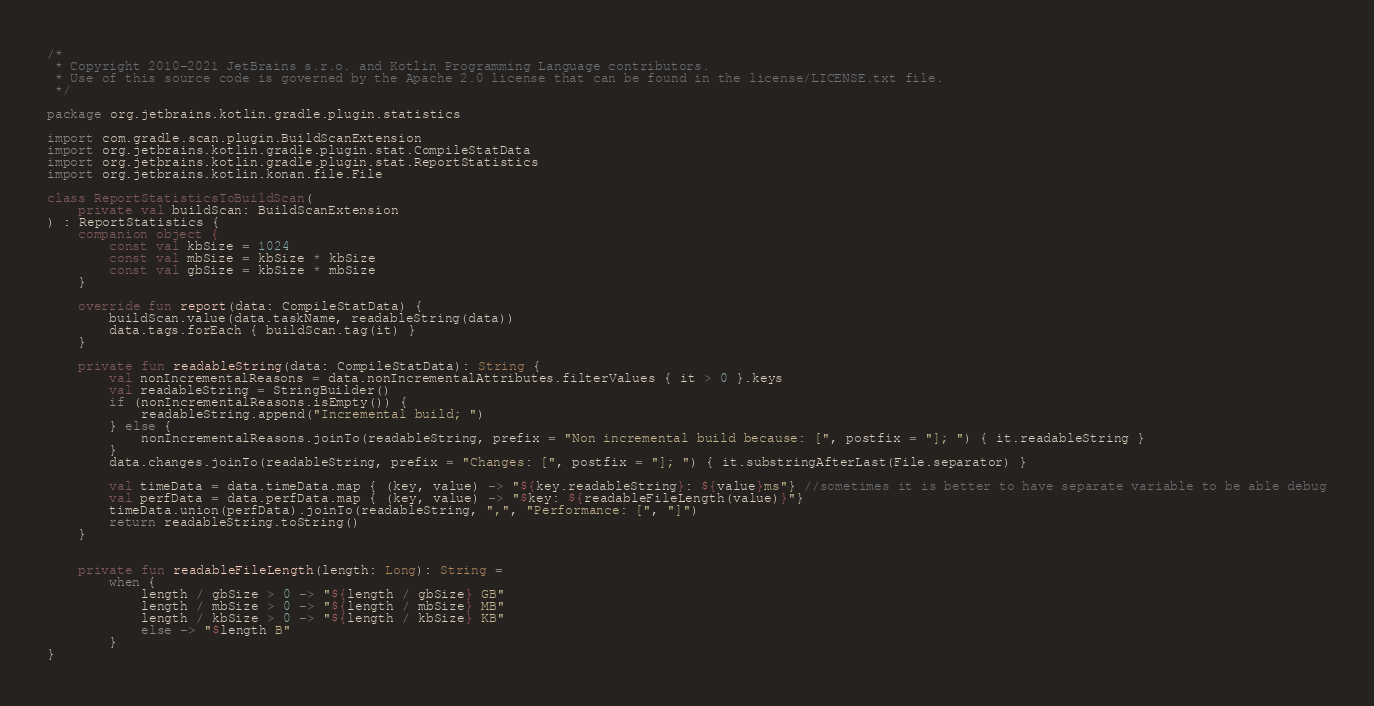Convert code to text. <code><loc_0><loc_0><loc_500><loc_500><_Kotlin_>/*
 * Copyright 2010-2021 JetBrains s.r.o. and Kotlin Programming Language contributors.
 * Use of this source code is governed by the Apache 2.0 license that can be found in the license/LICENSE.txt file.
 */

package org.jetbrains.kotlin.gradle.plugin.statistics

import com.gradle.scan.plugin.BuildScanExtension
import org.jetbrains.kotlin.gradle.plugin.stat.CompileStatData
import org.jetbrains.kotlin.gradle.plugin.stat.ReportStatistics
import org.jetbrains.kotlin.konan.file.File

class ReportStatisticsToBuildScan(
    private val buildScan: BuildScanExtension
) : ReportStatistics {
    companion object {
        const val kbSize = 1024
        const val mbSize = kbSize * kbSize
        const val gbSize = kbSize * mbSize
    }

    override fun report(data: CompileStatData) {
        buildScan.value(data.taskName, readableString(data))
        data.tags.forEach { buildScan.tag(it) }
    }

    private fun readableString(data: CompileStatData): String {
        val nonIncrementalReasons = data.nonIncrementalAttributes.filterValues { it > 0 }.keys
        val readableString = StringBuilder()
        if (nonIncrementalReasons.isEmpty()) {
            readableString.append("Incremental build; ")
        } else {
            nonIncrementalReasons.joinTo(readableString, prefix = "Non incremental build because: [", postfix = "]; ") { it.readableString }
        }
        data.changes.joinTo(readableString, prefix = "Changes: [", postfix = "]; ") { it.substringAfterLast(File.separator) }

        val timeData = data.timeData.map { (key, value) -> "${key.readableString}: ${value}ms"} //sometimes it is better to have separate variable to be able debug
        val perfData = data.perfData.map { (key, value) -> "$key: ${readableFileLength(value)}"}
        timeData.union(perfData).joinTo(readableString, ",", "Performance: [", "]")
        return readableString.toString()
    }


    private fun readableFileLength(length: Long): String =
        when {
            length / gbSize > 0 -> "${length / gbSize} GB"
            length / mbSize > 0 -> "${length / mbSize} MB"
            length / kbSize > 0 -> "${length / kbSize} KB"
            else -> "$length B"
        }
}
</code> 